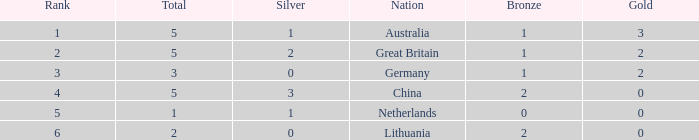What is the average for silver when bronze is less than 1, and gold is more than 0? None. 